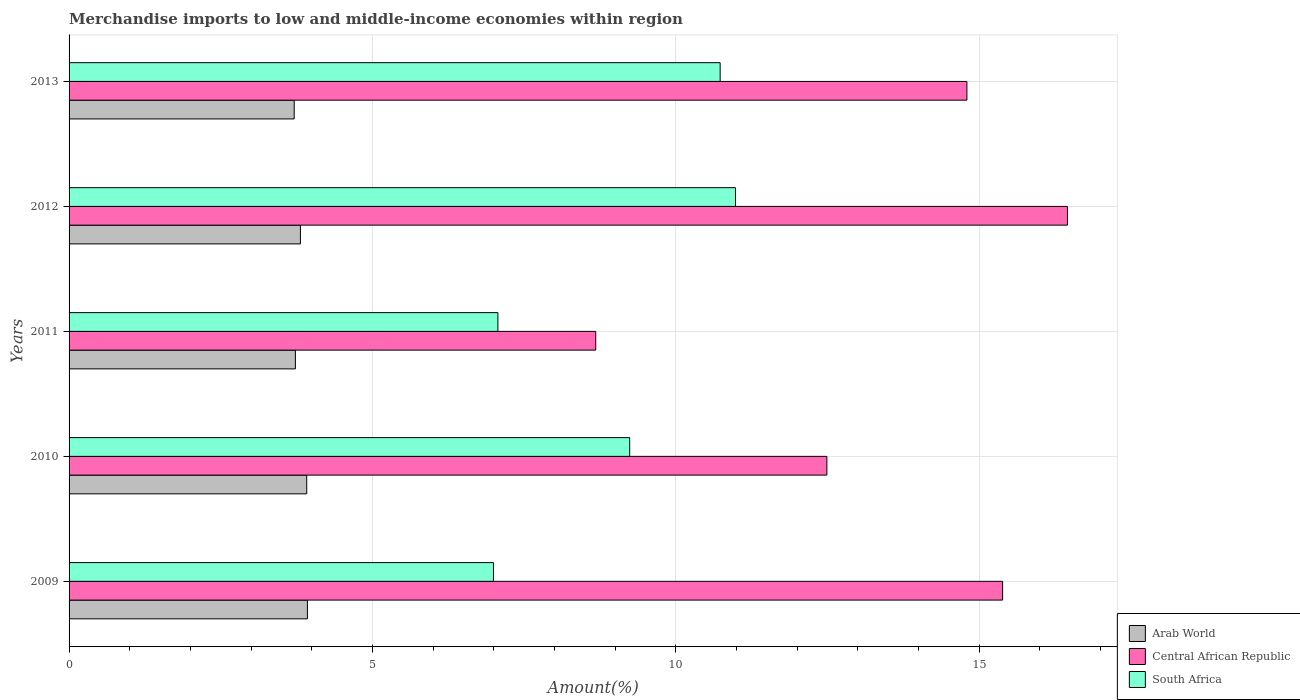How many different coloured bars are there?
Your answer should be compact. 3. Are the number of bars per tick equal to the number of legend labels?
Your response must be concise. Yes. Are the number of bars on each tick of the Y-axis equal?
Give a very brief answer. Yes. How many bars are there on the 2nd tick from the top?
Provide a short and direct response. 3. How many bars are there on the 5th tick from the bottom?
Ensure brevity in your answer.  3. In how many cases, is the number of bars for a given year not equal to the number of legend labels?
Provide a short and direct response. 0. What is the percentage of amount earned from merchandise imports in Arab World in 2009?
Provide a short and direct response. 3.93. Across all years, what is the maximum percentage of amount earned from merchandise imports in South Africa?
Your response must be concise. 10.98. Across all years, what is the minimum percentage of amount earned from merchandise imports in Central African Republic?
Your response must be concise. 8.68. In which year was the percentage of amount earned from merchandise imports in South Africa maximum?
Make the answer very short. 2012. In which year was the percentage of amount earned from merchandise imports in Arab World minimum?
Offer a very short reply. 2013. What is the total percentage of amount earned from merchandise imports in Arab World in the graph?
Offer a terse response. 19.1. What is the difference between the percentage of amount earned from merchandise imports in Central African Republic in 2011 and that in 2012?
Provide a succinct answer. -7.77. What is the difference between the percentage of amount earned from merchandise imports in Central African Republic in 2011 and the percentage of amount earned from merchandise imports in Arab World in 2012?
Keep it short and to the point. 4.87. What is the average percentage of amount earned from merchandise imports in Arab World per year?
Provide a short and direct response. 3.82. In the year 2012, what is the difference between the percentage of amount earned from merchandise imports in Arab World and percentage of amount earned from merchandise imports in Central African Republic?
Provide a succinct answer. -12.64. What is the ratio of the percentage of amount earned from merchandise imports in Central African Republic in 2009 to that in 2011?
Your response must be concise. 1.77. Is the difference between the percentage of amount earned from merchandise imports in Arab World in 2011 and 2013 greater than the difference between the percentage of amount earned from merchandise imports in Central African Republic in 2011 and 2013?
Offer a very short reply. Yes. What is the difference between the highest and the second highest percentage of amount earned from merchandise imports in South Africa?
Your response must be concise. 0.25. What is the difference between the highest and the lowest percentage of amount earned from merchandise imports in South Africa?
Offer a terse response. 3.99. In how many years, is the percentage of amount earned from merchandise imports in Arab World greater than the average percentage of amount earned from merchandise imports in Arab World taken over all years?
Give a very brief answer. 2. What does the 2nd bar from the top in 2010 represents?
Make the answer very short. Central African Republic. What does the 2nd bar from the bottom in 2009 represents?
Give a very brief answer. Central African Republic. Is it the case that in every year, the sum of the percentage of amount earned from merchandise imports in South Africa and percentage of amount earned from merchandise imports in Arab World is greater than the percentage of amount earned from merchandise imports in Central African Republic?
Make the answer very short. No. What is the difference between two consecutive major ticks on the X-axis?
Provide a short and direct response. 5. Are the values on the major ticks of X-axis written in scientific E-notation?
Provide a short and direct response. No. How many legend labels are there?
Your response must be concise. 3. How are the legend labels stacked?
Offer a terse response. Vertical. What is the title of the graph?
Offer a very short reply. Merchandise imports to low and middle-income economies within region. What is the label or title of the X-axis?
Your answer should be compact. Amount(%). What is the label or title of the Y-axis?
Ensure brevity in your answer.  Years. What is the Amount(%) in Arab World in 2009?
Offer a terse response. 3.93. What is the Amount(%) of Central African Republic in 2009?
Ensure brevity in your answer.  15.39. What is the Amount(%) of South Africa in 2009?
Your response must be concise. 6.99. What is the Amount(%) in Arab World in 2010?
Provide a short and direct response. 3.92. What is the Amount(%) of Central African Republic in 2010?
Give a very brief answer. 12.49. What is the Amount(%) of South Africa in 2010?
Offer a terse response. 9.24. What is the Amount(%) in Arab World in 2011?
Your answer should be compact. 3.73. What is the Amount(%) in Central African Republic in 2011?
Your response must be concise. 8.68. What is the Amount(%) of South Africa in 2011?
Your response must be concise. 7.07. What is the Amount(%) of Arab World in 2012?
Give a very brief answer. 3.81. What is the Amount(%) of Central African Republic in 2012?
Your response must be concise. 16.45. What is the Amount(%) of South Africa in 2012?
Provide a short and direct response. 10.98. What is the Amount(%) of Arab World in 2013?
Offer a terse response. 3.71. What is the Amount(%) in Central African Republic in 2013?
Offer a very short reply. 14.8. What is the Amount(%) in South Africa in 2013?
Make the answer very short. 10.73. Across all years, what is the maximum Amount(%) of Arab World?
Give a very brief answer. 3.93. Across all years, what is the maximum Amount(%) of Central African Republic?
Provide a succinct answer. 16.45. Across all years, what is the maximum Amount(%) in South Africa?
Offer a terse response. 10.98. Across all years, what is the minimum Amount(%) in Arab World?
Your answer should be compact. 3.71. Across all years, what is the minimum Amount(%) in Central African Republic?
Keep it short and to the point. 8.68. Across all years, what is the minimum Amount(%) in South Africa?
Your answer should be very brief. 6.99. What is the total Amount(%) of Arab World in the graph?
Your answer should be compact. 19.1. What is the total Amount(%) of Central African Republic in the graph?
Your response must be concise. 67.8. What is the total Amount(%) of South Africa in the graph?
Provide a short and direct response. 45.01. What is the difference between the Amount(%) in Arab World in 2009 and that in 2010?
Offer a terse response. 0.01. What is the difference between the Amount(%) in Central African Republic in 2009 and that in 2010?
Your response must be concise. 2.9. What is the difference between the Amount(%) of South Africa in 2009 and that in 2010?
Offer a very short reply. -2.25. What is the difference between the Amount(%) of Arab World in 2009 and that in 2011?
Give a very brief answer. 0.2. What is the difference between the Amount(%) in Central African Republic in 2009 and that in 2011?
Your response must be concise. 6.71. What is the difference between the Amount(%) of South Africa in 2009 and that in 2011?
Make the answer very short. -0.07. What is the difference between the Amount(%) of Arab World in 2009 and that in 2012?
Provide a succinct answer. 0.12. What is the difference between the Amount(%) of Central African Republic in 2009 and that in 2012?
Your answer should be compact. -1.07. What is the difference between the Amount(%) of South Africa in 2009 and that in 2012?
Provide a short and direct response. -3.99. What is the difference between the Amount(%) in Arab World in 2009 and that in 2013?
Your answer should be very brief. 0.22. What is the difference between the Amount(%) in Central African Republic in 2009 and that in 2013?
Ensure brevity in your answer.  0.59. What is the difference between the Amount(%) in South Africa in 2009 and that in 2013?
Ensure brevity in your answer.  -3.74. What is the difference between the Amount(%) in Arab World in 2010 and that in 2011?
Keep it short and to the point. 0.19. What is the difference between the Amount(%) in Central African Republic in 2010 and that in 2011?
Make the answer very short. 3.81. What is the difference between the Amount(%) of South Africa in 2010 and that in 2011?
Provide a short and direct response. 2.17. What is the difference between the Amount(%) of Arab World in 2010 and that in 2012?
Make the answer very short. 0.1. What is the difference between the Amount(%) of Central African Republic in 2010 and that in 2012?
Your response must be concise. -3.96. What is the difference between the Amount(%) in South Africa in 2010 and that in 2012?
Make the answer very short. -1.74. What is the difference between the Amount(%) in Arab World in 2010 and that in 2013?
Keep it short and to the point. 0.21. What is the difference between the Amount(%) in Central African Republic in 2010 and that in 2013?
Offer a terse response. -2.31. What is the difference between the Amount(%) in South Africa in 2010 and that in 2013?
Your answer should be very brief. -1.49. What is the difference between the Amount(%) in Arab World in 2011 and that in 2012?
Ensure brevity in your answer.  -0.08. What is the difference between the Amount(%) of Central African Republic in 2011 and that in 2012?
Offer a terse response. -7.77. What is the difference between the Amount(%) of South Africa in 2011 and that in 2012?
Offer a terse response. -3.92. What is the difference between the Amount(%) in Arab World in 2011 and that in 2013?
Ensure brevity in your answer.  0.02. What is the difference between the Amount(%) of Central African Republic in 2011 and that in 2013?
Your answer should be compact. -6.12. What is the difference between the Amount(%) in South Africa in 2011 and that in 2013?
Give a very brief answer. -3.66. What is the difference between the Amount(%) in Arab World in 2012 and that in 2013?
Give a very brief answer. 0.1. What is the difference between the Amount(%) in Central African Republic in 2012 and that in 2013?
Offer a terse response. 1.66. What is the difference between the Amount(%) of South Africa in 2012 and that in 2013?
Provide a succinct answer. 0.25. What is the difference between the Amount(%) of Arab World in 2009 and the Amount(%) of Central African Republic in 2010?
Offer a terse response. -8.56. What is the difference between the Amount(%) of Arab World in 2009 and the Amount(%) of South Africa in 2010?
Make the answer very short. -5.31. What is the difference between the Amount(%) in Central African Republic in 2009 and the Amount(%) in South Africa in 2010?
Ensure brevity in your answer.  6.15. What is the difference between the Amount(%) in Arab World in 2009 and the Amount(%) in Central African Republic in 2011?
Your response must be concise. -4.75. What is the difference between the Amount(%) of Arab World in 2009 and the Amount(%) of South Africa in 2011?
Your answer should be compact. -3.14. What is the difference between the Amount(%) of Central African Republic in 2009 and the Amount(%) of South Africa in 2011?
Ensure brevity in your answer.  8.32. What is the difference between the Amount(%) of Arab World in 2009 and the Amount(%) of Central African Republic in 2012?
Give a very brief answer. -12.53. What is the difference between the Amount(%) in Arab World in 2009 and the Amount(%) in South Africa in 2012?
Make the answer very short. -7.05. What is the difference between the Amount(%) in Central African Republic in 2009 and the Amount(%) in South Africa in 2012?
Give a very brief answer. 4.4. What is the difference between the Amount(%) of Arab World in 2009 and the Amount(%) of Central African Republic in 2013?
Offer a terse response. -10.87. What is the difference between the Amount(%) in Arab World in 2009 and the Amount(%) in South Africa in 2013?
Provide a short and direct response. -6.8. What is the difference between the Amount(%) of Central African Republic in 2009 and the Amount(%) of South Africa in 2013?
Offer a terse response. 4.65. What is the difference between the Amount(%) in Arab World in 2010 and the Amount(%) in Central African Republic in 2011?
Offer a terse response. -4.76. What is the difference between the Amount(%) in Arab World in 2010 and the Amount(%) in South Africa in 2011?
Your answer should be very brief. -3.15. What is the difference between the Amount(%) of Central African Republic in 2010 and the Amount(%) of South Africa in 2011?
Provide a short and direct response. 5.42. What is the difference between the Amount(%) in Arab World in 2010 and the Amount(%) in Central African Republic in 2012?
Make the answer very short. -12.54. What is the difference between the Amount(%) of Arab World in 2010 and the Amount(%) of South Africa in 2012?
Provide a succinct answer. -7.07. What is the difference between the Amount(%) in Central African Republic in 2010 and the Amount(%) in South Africa in 2012?
Ensure brevity in your answer.  1.51. What is the difference between the Amount(%) in Arab World in 2010 and the Amount(%) in Central African Republic in 2013?
Make the answer very short. -10.88. What is the difference between the Amount(%) of Arab World in 2010 and the Amount(%) of South Africa in 2013?
Keep it short and to the point. -6.81. What is the difference between the Amount(%) of Central African Republic in 2010 and the Amount(%) of South Africa in 2013?
Keep it short and to the point. 1.76. What is the difference between the Amount(%) of Arab World in 2011 and the Amount(%) of Central African Republic in 2012?
Provide a succinct answer. -12.72. What is the difference between the Amount(%) of Arab World in 2011 and the Amount(%) of South Africa in 2012?
Your answer should be very brief. -7.25. What is the difference between the Amount(%) in Central African Republic in 2011 and the Amount(%) in South Africa in 2012?
Make the answer very short. -2.3. What is the difference between the Amount(%) of Arab World in 2011 and the Amount(%) of Central African Republic in 2013?
Give a very brief answer. -11.07. What is the difference between the Amount(%) of Arab World in 2011 and the Amount(%) of South Africa in 2013?
Give a very brief answer. -7. What is the difference between the Amount(%) in Central African Republic in 2011 and the Amount(%) in South Africa in 2013?
Ensure brevity in your answer.  -2.05. What is the difference between the Amount(%) in Arab World in 2012 and the Amount(%) in Central African Republic in 2013?
Your response must be concise. -10.98. What is the difference between the Amount(%) of Arab World in 2012 and the Amount(%) of South Africa in 2013?
Keep it short and to the point. -6.92. What is the difference between the Amount(%) in Central African Republic in 2012 and the Amount(%) in South Africa in 2013?
Keep it short and to the point. 5.72. What is the average Amount(%) of Arab World per year?
Your answer should be compact. 3.82. What is the average Amount(%) in Central African Republic per year?
Provide a short and direct response. 13.56. What is the average Amount(%) of South Africa per year?
Your answer should be compact. 9. In the year 2009, what is the difference between the Amount(%) of Arab World and Amount(%) of Central African Republic?
Your answer should be compact. -11.46. In the year 2009, what is the difference between the Amount(%) in Arab World and Amount(%) in South Africa?
Offer a terse response. -3.07. In the year 2009, what is the difference between the Amount(%) in Central African Republic and Amount(%) in South Africa?
Make the answer very short. 8.39. In the year 2010, what is the difference between the Amount(%) of Arab World and Amount(%) of Central African Republic?
Offer a very short reply. -8.57. In the year 2010, what is the difference between the Amount(%) in Arab World and Amount(%) in South Africa?
Offer a very short reply. -5.32. In the year 2010, what is the difference between the Amount(%) of Central African Republic and Amount(%) of South Africa?
Provide a short and direct response. 3.25. In the year 2011, what is the difference between the Amount(%) of Arab World and Amount(%) of Central African Republic?
Keep it short and to the point. -4.95. In the year 2011, what is the difference between the Amount(%) of Arab World and Amount(%) of South Africa?
Provide a short and direct response. -3.34. In the year 2011, what is the difference between the Amount(%) of Central African Republic and Amount(%) of South Africa?
Your answer should be very brief. 1.61. In the year 2012, what is the difference between the Amount(%) of Arab World and Amount(%) of Central African Republic?
Give a very brief answer. -12.64. In the year 2012, what is the difference between the Amount(%) of Arab World and Amount(%) of South Africa?
Ensure brevity in your answer.  -7.17. In the year 2012, what is the difference between the Amount(%) in Central African Republic and Amount(%) in South Africa?
Your answer should be compact. 5.47. In the year 2013, what is the difference between the Amount(%) of Arab World and Amount(%) of Central African Republic?
Make the answer very short. -11.09. In the year 2013, what is the difference between the Amount(%) in Arab World and Amount(%) in South Africa?
Provide a short and direct response. -7.02. In the year 2013, what is the difference between the Amount(%) in Central African Republic and Amount(%) in South Africa?
Offer a terse response. 4.07. What is the ratio of the Amount(%) in Arab World in 2009 to that in 2010?
Provide a short and direct response. 1. What is the ratio of the Amount(%) in Central African Republic in 2009 to that in 2010?
Your answer should be very brief. 1.23. What is the ratio of the Amount(%) of South Africa in 2009 to that in 2010?
Make the answer very short. 0.76. What is the ratio of the Amount(%) in Arab World in 2009 to that in 2011?
Keep it short and to the point. 1.05. What is the ratio of the Amount(%) of Central African Republic in 2009 to that in 2011?
Provide a short and direct response. 1.77. What is the ratio of the Amount(%) of South Africa in 2009 to that in 2011?
Provide a short and direct response. 0.99. What is the ratio of the Amount(%) in Arab World in 2009 to that in 2012?
Your answer should be compact. 1.03. What is the ratio of the Amount(%) of Central African Republic in 2009 to that in 2012?
Your response must be concise. 0.94. What is the ratio of the Amount(%) of South Africa in 2009 to that in 2012?
Your answer should be very brief. 0.64. What is the ratio of the Amount(%) of Arab World in 2009 to that in 2013?
Offer a terse response. 1.06. What is the ratio of the Amount(%) of Central African Republic in 2009 to that in 2013?
Provide a succinct answer. 1.04. What is the ratio of the Amount(%) in South Africa in 2009 to that in 2013?
Your response must be concise. 0.65. What is the ratio of the Amount(%) in Central African Republic in 2010 to that in 2011?
Keep it short and to the point. 1.44. What is the ratio of the Amount(%) of South Africa in 2010 to that in 2011?
Give a very brief answer. 1.31. What is the ratio of the Amount(%) of Arab World in 2010 to that in 2012?
Your response must be concise. 1.03. What is the ratio of the Amount(%) in Central African Republic in 2010 to that in 2012?
Your answer should be very brief. 0.76. What is the ratio of the Amount(%) in South Africa in 2010 to that in 2012?
Give a very brief answer. 0.84. What is the ratio of the Amount(%) in Arab World in 2010 to that in 2013?
Provide a succinct answer. 1.06. What is the ratio of the Amount(%) in Central African Republic in 2010 to that in 2013?
Keep it short and to the point. 0.84. What is the ratio of the Amount(%) in South Africa in 2010 to that in 2013?
Your response must be concise. 0.86. What is the ratio of the Amount(%) of Arab World in 2011 to that in 2012?
Your response must be concise. 0.98. What is the ratio of the Amount(%) in Central African Republic in 2011 to that in 2012?
Your response must be concise. 0.53. What is the ratio of the Amount(%) of South Africa in 2011 to that in 2012?
Make the answer very short. 0.64. What is the ratio of the Amount(%) in Central African Republic in 2011 to that in 2013?
Offer a very short reply. 0.59. What is the ratio of the Amount(%) of South Africa in 2011 to that in 2013?
Your response must be concise. 0.66. What is the ratio of the Amount(%) of Arab World in 2012 to that in 2013?
Keep it short and to the point. 1.03. What is the ratio of the Amount(%) in Central African Republic in 2012 to that in 2013?
Ensure brevity in your answer.  1.11. What is the ratio of the Amount(%) in South Africa in 2012 to that in 2013?
Ensure brevity in your answer.  1.02. What is the difference between the highest and the second highest Amount(%) in Arab World?
Offer a very short reply. 0.01. What is the difference between the highest and the second highest Amount(%) in Central African Republic?
Keep it short and to the point. 1.07. What is the difference between the highest and the second highest Amount(%) in South Africa?
Provide a succinct answer. 0.25. What is the difference between the highest and the lowest Amount(%) in Arab World?
Your answer should be compact. 0.22. What is the difference between the highest and the lowest Amount(%) in Central African Republic?
Offer a terse response. 7.77. What is the difference between the highest and the lowest Amount(%) of South Africa?
Your answer should be compact. 3.99. 